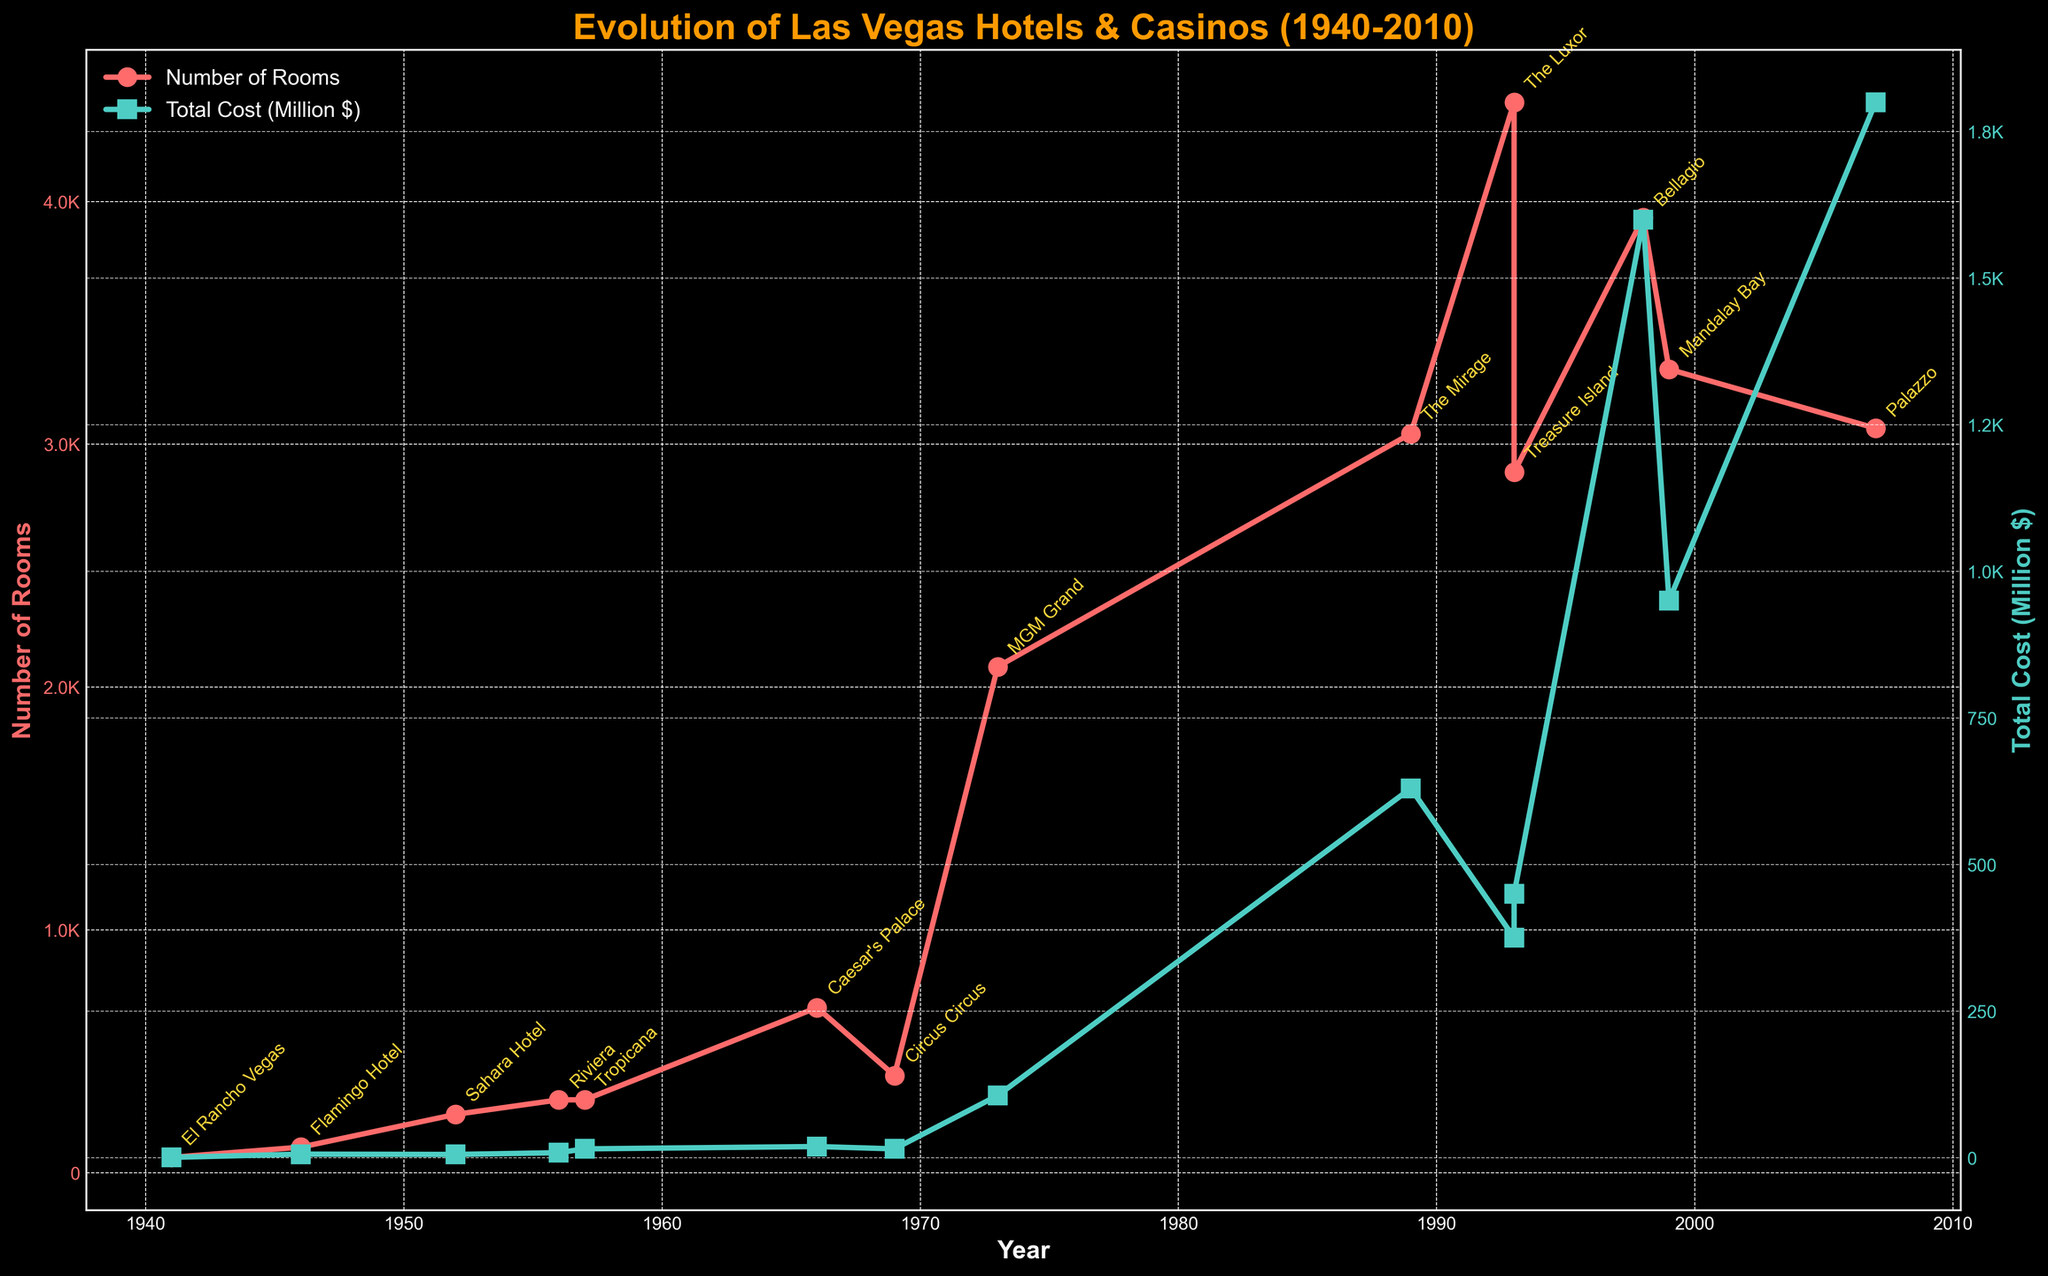How many hotel-casinos are represented in the plot between 1940 and 2010? Count each unique hotel-casino on the plot. There are data points for 14 hotel-casinos.
Answer: 14 What is the trend in the number of rooms from 1941 to 2007? Observe the pattern of the red line representing the number of rooms. It generally increases over time, indicating hotel-casinos are getting larger.
Answer: It increases Which hotel-casino had the highest number of rooms, and in what year was it built? Note the peak value of the red line and find the corresponding year and hotel-casino label. The Luxor, built in 1993, had the highest number of rooms at 4408.
Answer: The Luxor, 1993 How does the cost of hotel-casino construction change over time? Observe the pattern of the green line representing the total cost. The total cost generally increases over time, with significant jumps in the late 20th century.
Answer: It increases Which hotel-casino had the highest construction cost and how much was it? Note the peak value of the green line and find the corresponding total cost. The Bellagio, built in 1998, had the highest construction cost at $1600 million.
Answer: The Bellagio, 1600 million What is the difference in the number of rooms between Circus Circus and The Mirage? Identify the values for Circus Circus (400 rooms) and The Mirage (3044 rooms). Then, subtract the smaller number from the larger number. 3044 - 400 = 2644.
Answer: 2644 Which decade saw the construction of the most hotel-casinos? Count the number of hotel-casinos built in each decade. The 1990s had five hotel-casinos: The Mirage, The Luxor, Treasure Island, Bellagio, and Mandalay Bay.
Answer: 1990s Which notable features are associated with the hotel-casino built in 1941? Identify the label for the hotel-casino built in 1941; it's El Rancho Vegas. The notable feature is "First hotel on the Strip".
Answer: First hotel on the Strip How did the construction costs of the Sahara Hotel and Tropicana compare? Identify the total cost for Sahara Hotel ($5.5 million) and Tropicana ($15 million). Compare the numbers: $15 million is greater than $5.5 million.
Answer: Tropicana was costlier Which two hotel-casinos built around 1969-1973 had similar room capacities, and what were their capacities? Identify hotel-casinos built in this period: Circus Circus (400 rooms) and MGM Grand (2084 rooms). These two did not have similar capacities.
Answer: None 